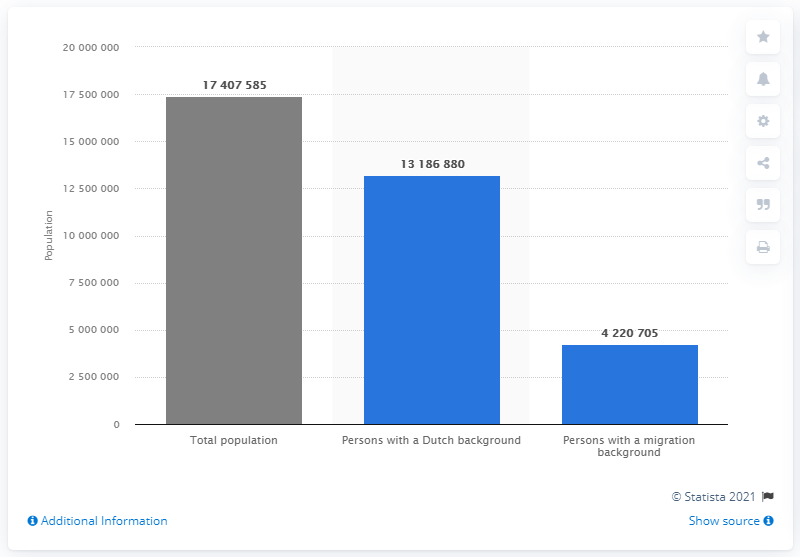List a handful of essential elements in this visual. In 2020, there were approximately 4,220,705 people in the Netherlands who had a migration background. In 2020, there were 17,407,585 people living in the Netherlands. 